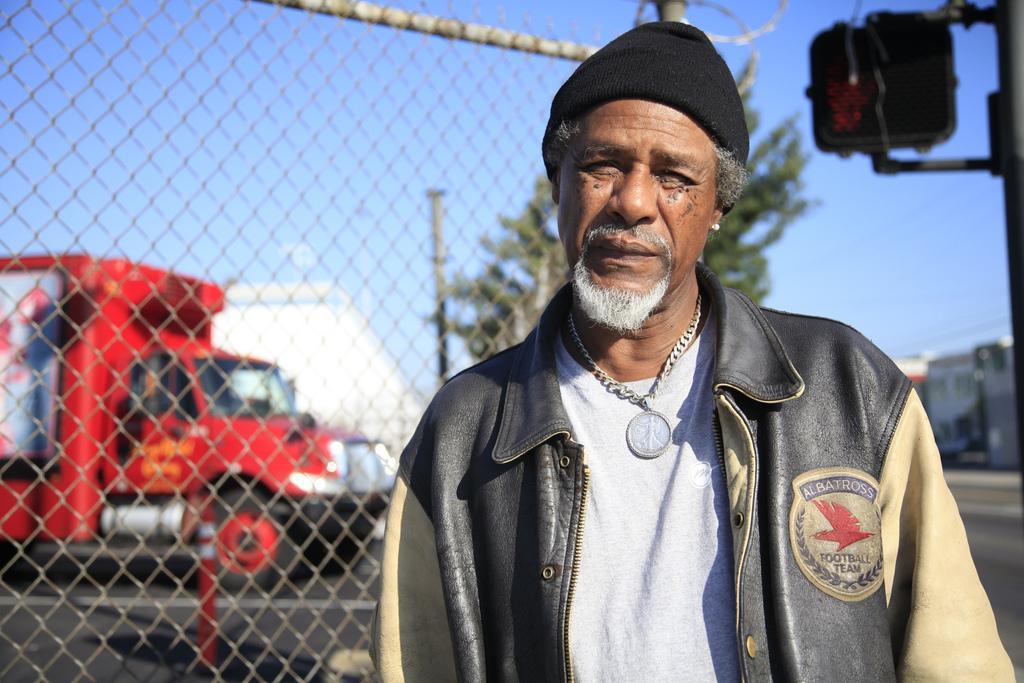Can you describe this image briefly? In this image there is a man standing. He is wearing a jacket, a cap and a chain. Behind him there is a net to the pole. To the right there are traffic signal lights to a pole. In the background there are houses, trees, poles and a road. There is a truck moving on the road. At the top there is the sky. 